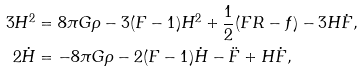Convert formula to latex. <formula><loc_0><loc_0><loc_500><loc_500>3 H ^ { 2 } & = 8 \pi G \rho - 3 ( F - 1 ) H ^ { 2 } + \frac { 1 } { 2 } ( F R - f ) - 3 H \dot { F } , \\ 2 \dot { H } & = - 8 \pi G \rho - 2 ( F - 1 ) \dot { H } - \ddot { F } + H \dot { F } ,</formula> 